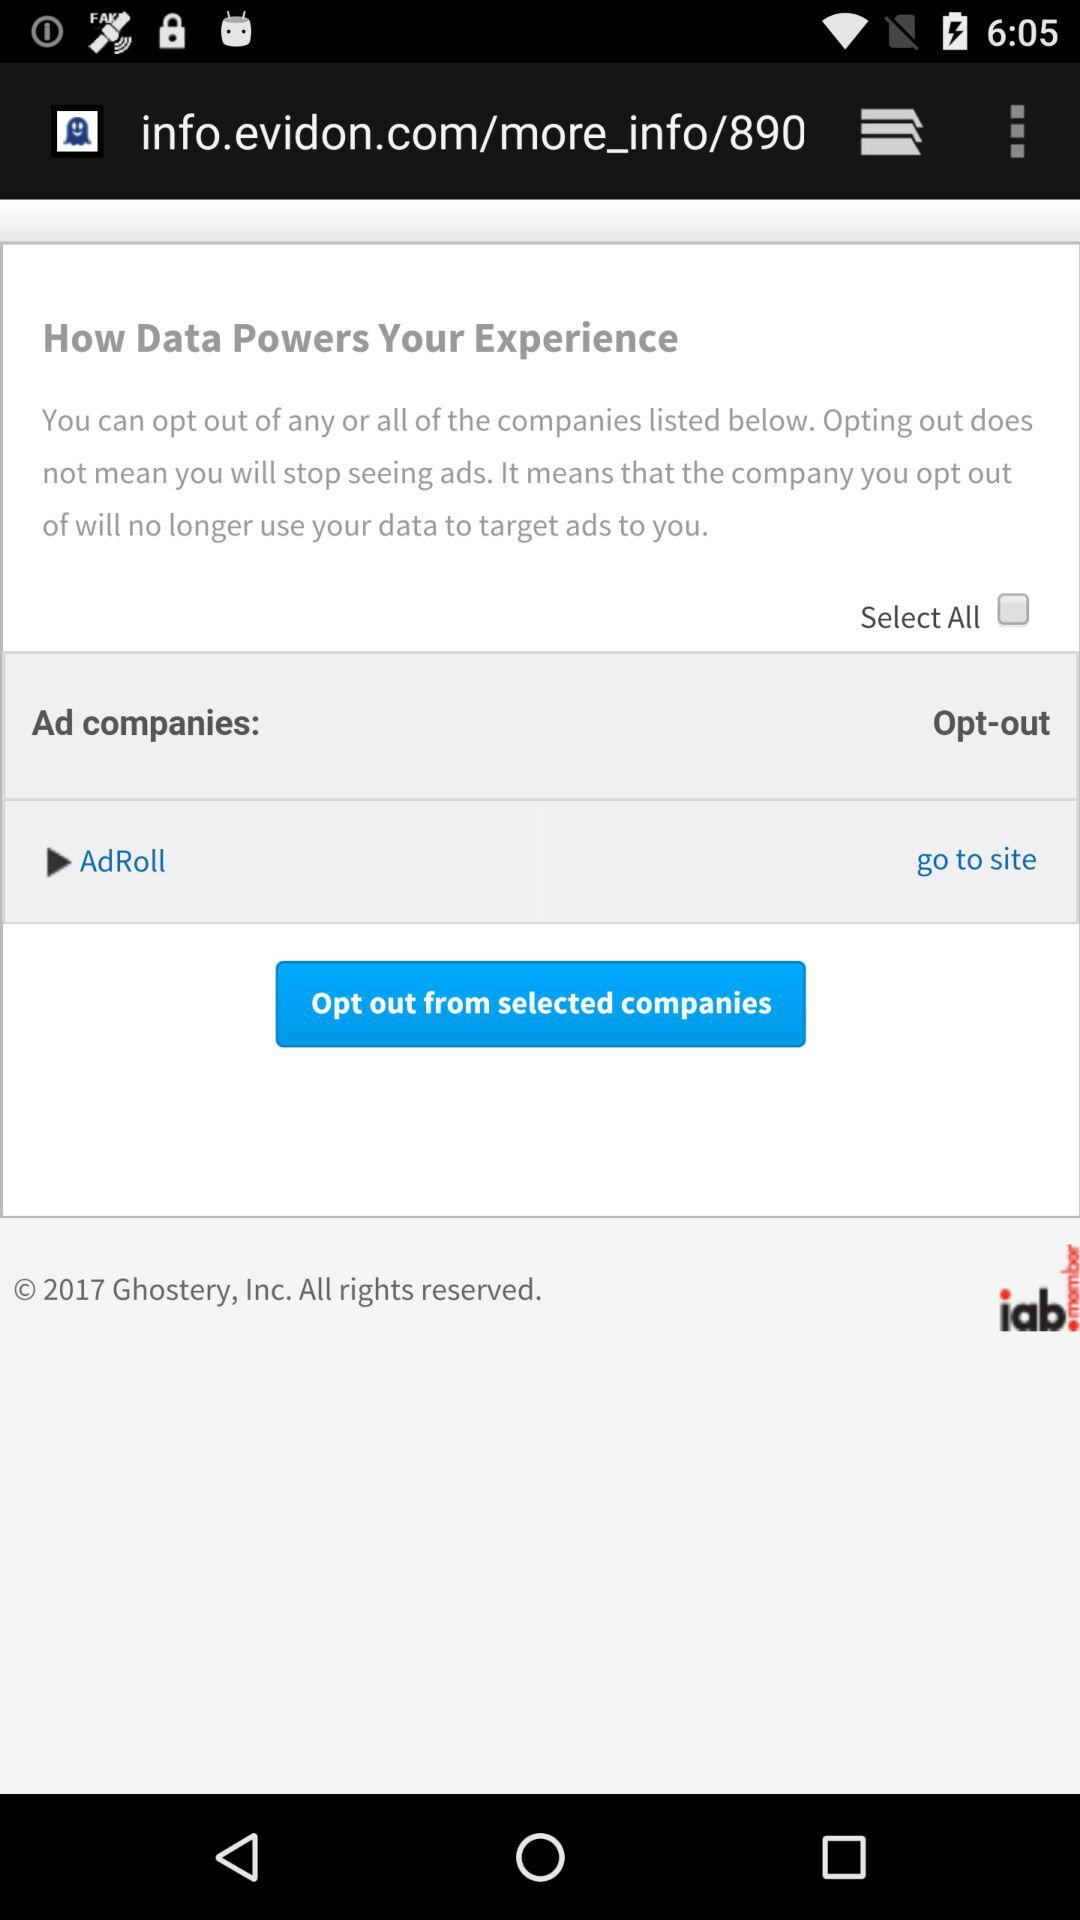How many companies can be selected at once?
Answer the question using a single word or phrase. All 